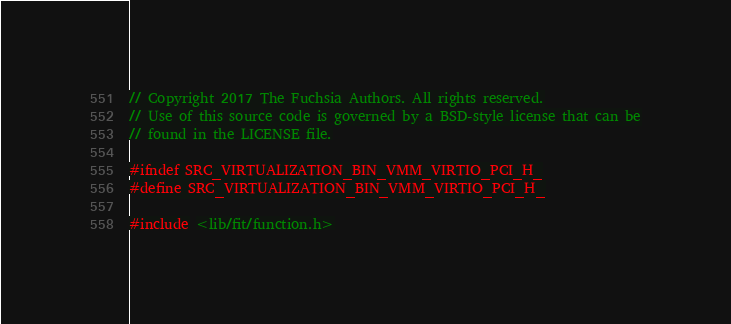Convert code to text. <code><loc_0><loc_0><loc_500><loc_500><_C_>// Copyright 2017 The Fuchsia Authors. All rights reserved.
// Use of this source code is governed by a BSD-style license that can be
// found in the LICENSE file.

#ifndef SRC_VIRTUALIZATION_BIN_VMM_VIRTIO_PCI_H_
#define SRC_VIRTUALIZATION_BIN_VMM_VIRTIO_PCI_H_

#include <lib/fit/function.h></code> 